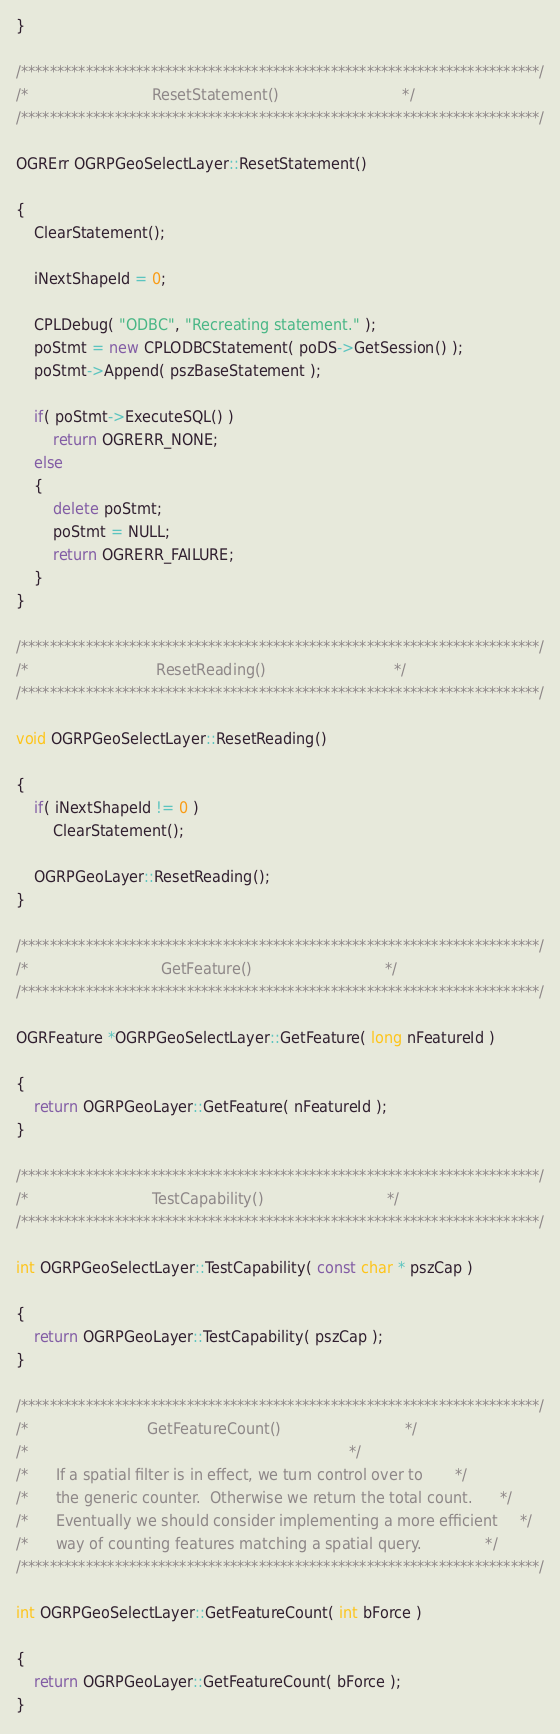Convert code to text. <code><loc_0><loc_0><loc_500><loc_500><_C++_>}

/************************************************************************/
/*                           ResetStatement()                           */
/************************************************************************/

OGRErr OGRPGeoSelectLayer::ResetStatement()

{
    ClearStatement();

    iNextShapeId = 0;

    CPLDebug( "ODBC", "Recreating statement." );
    poStmt = new CPLODBCStatement( poDS->GetSession() );
    poStmt->Append( pszBaseStatement );

    if( poStmt->ExecuteSQL() )
        return OGRERR_NONE;
    else
    {
        delete poStmt;
        poStmt = NULL;
        return OGRERR_FAILURE;
    }
}

/************************************************************************/
/*                            ResetReading()                            */
/************************************************************************/

void OGRPGeoSelectLayer::ResetReading()

{
    if( iNextShapeId != 0 )
        ClearStatement();

    OGRPGeoLayer::ResetReading();
}

/************************************************************************/
/*                             GetFeature()                             */
/************************************************************************/

OGRFeature *OGRPGeoSelectLayer::GetFeature( long nFeatureId )

{
    return OGRPGeoLayer::GetFeature( nFeatureId );
}

/************************************************************************/
/*                           TestCapability()                           */
/************************************************************************/

int OGRPGeoSelectLayer::TestCapability( const char * pszCap )

{
    return OGRPGeoLayer::TestCapability( pszCap );
}

/************************************************************************/
/*                          GetFeatureCount()                           */
/*                                                                      */
/*      If a spatial filter is in effect, we turn control over to       */
/*      the generic counter.  Otherwise we return the total count.      */
/*      Eventually we should consider implementing a more efficient     */
/*      way of counting features matching a spatial query.              */
/************************************************************************/

int OGRPGeoSelectLayer::GetFeatureCount( int bForce )

{
    return OGRPGeoLayer::GetFeatureCount( bForce );
}
</code> 